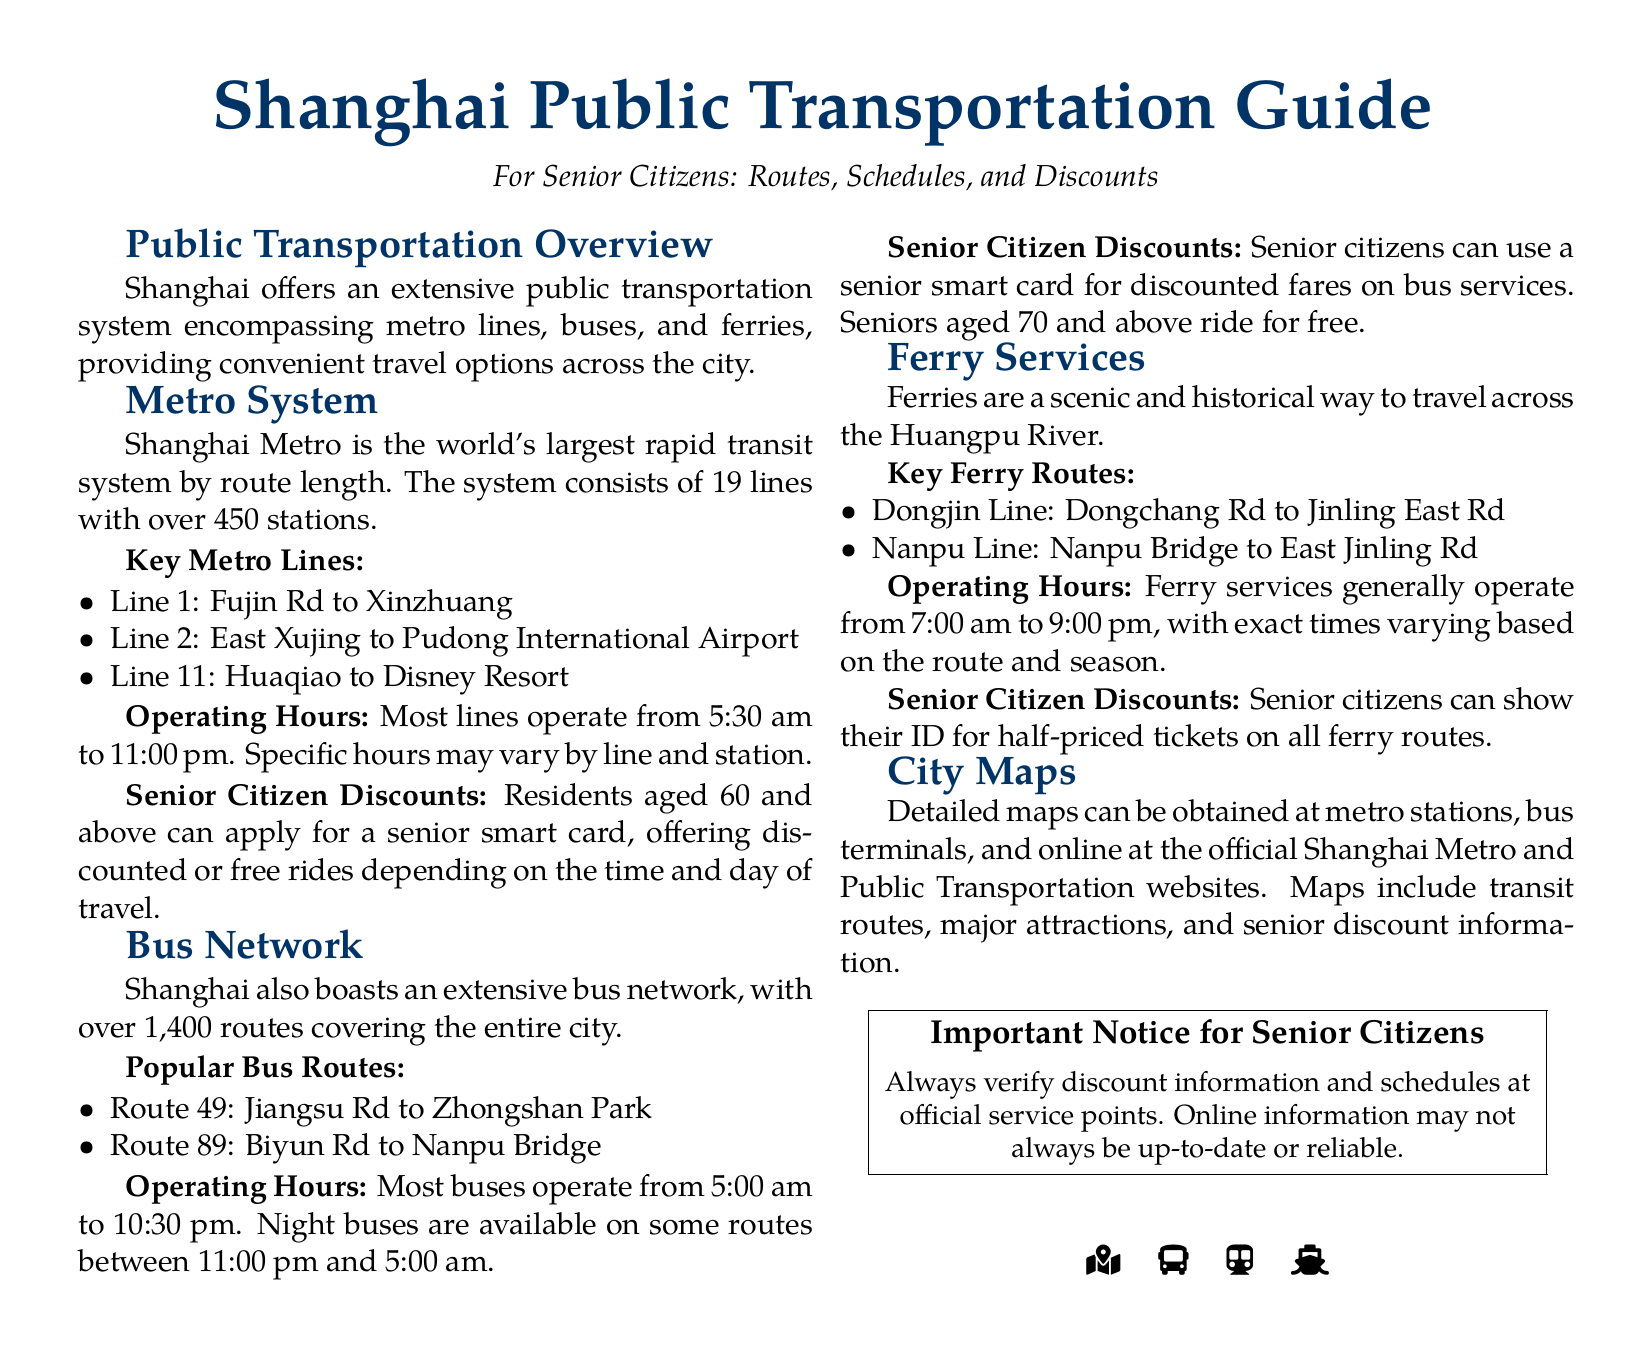What is the maximum number of metro lines in Shanghai? The maximum number of metro lines in Shanghai is 19.
Answer: 19 What age is required to obtain a senior smart card? The age required to obtain a senior smart card is 60 and above.
Answer: 60 What is the earliest operating time for the metro? The earliest operating time for the metro is 5:30 am.
Answer: 5:30 am What do senior citizens need to show for ferry discounts? Senior citizens need to show their ID for half-priced tickets on all ferry routes.
Answer: ID What is the latest time most buses operate till? The latest time most buses operate till is 10:30 pm.
Answer: 10:30 pm How many bus routes are available in Shanghai? There are over 1,400 bus routes available in Shanghai.
Answer: 1,400 What is the fare discount for seniors aged 70 and above on buses? Seniors aged 70 and above ride for free.
Answer: Free Where can detailed city maps be obtained? Detailed city maps can be obtained at metro stations and bus terminals.
Answer: Metro stations and bus terminals 